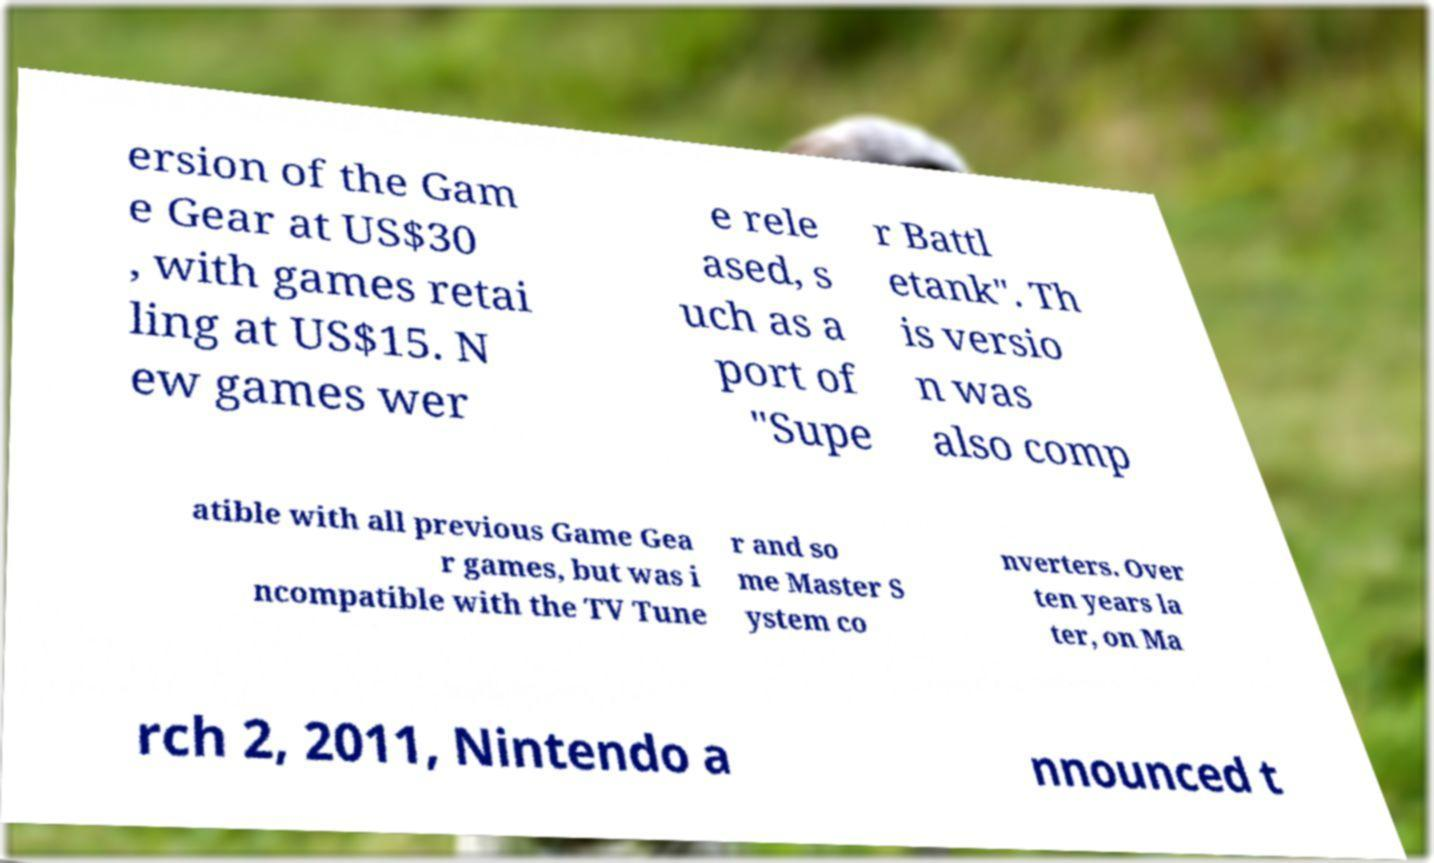Can you read and provide the text displayed in the image?This photo seems to have some interesting text. Can you extract and type it out for me? ersion of the Gam e Gear at US$30 , with games retai ling at US$15. N ew games wer e rele ased, s uch as a port of "Supe r Battl etank". Th is versio n was also comp atible with all previous Game Gea r games, but was i ncompatible with the TV Tune r and so me Master S ystem co nverters. Over ten years la ter, on Ma rch 2, 2011, Nintendo a nnounced t 